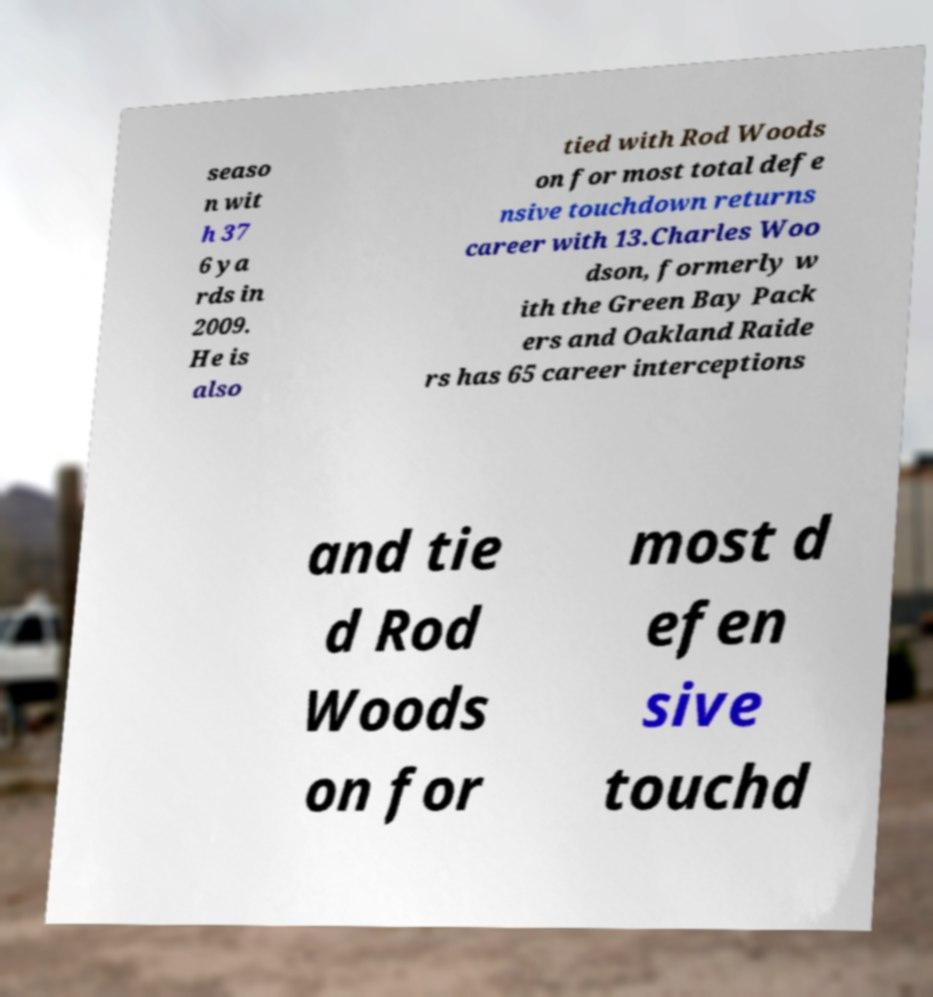Please read and relay the text visible in this image. What does it say? seaso n wit h 37 6 ya rds in 2009. He is also tied with Rod Woods on for most total defe nsive touchdown returns career with 13.Charles Woo dson, formerly w ith the Green Bay Pack ers and Oakland Raide rs has 65 career interceptions and tie d Rod Woods on for most d efen sive touchd 